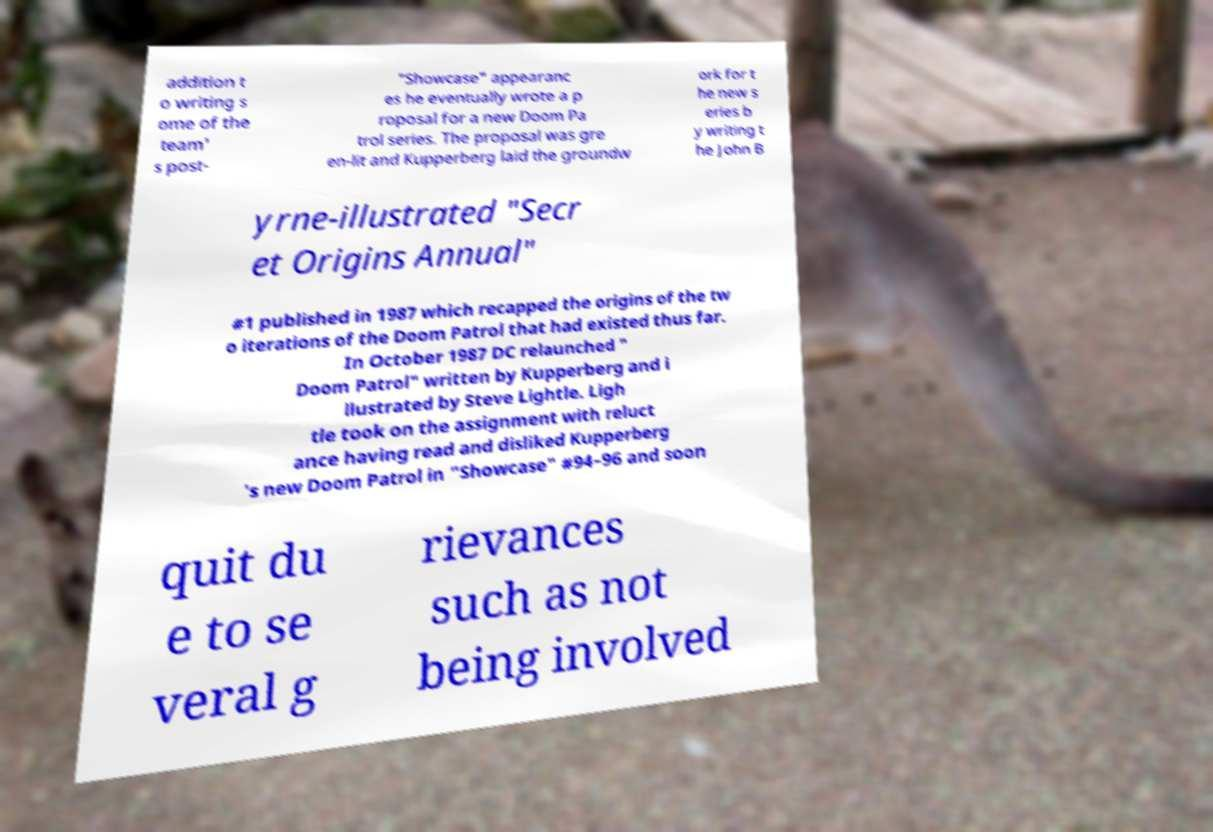Please read and relay the text visible in this image. What does it say? addition t o writing s ome of the team' s post- "Showcase" appearanc es he eventually wrote a p roposal for a new Doom Pa trol series. The proposal was gre en-lit and Kupperberg laid the groundw ork for t he new s eries b y writing t he John B yrne-illustrated "Secr et Origins Annual" #1 published in 1987 which recapped the origins of the tw o iterations of the Doom Patrol that had existed thus far. In October 1987 DC relaunched " Doom Patrol" written by Kupperberg and i llustrated by Steve Lightle. Ligh tle took on the assignment with reluct ance having read and disliked Kupperberg 's new Doom Patrol in "Showcase" #94–96 and soon quit du e to se veral g rievances such as not being involved 